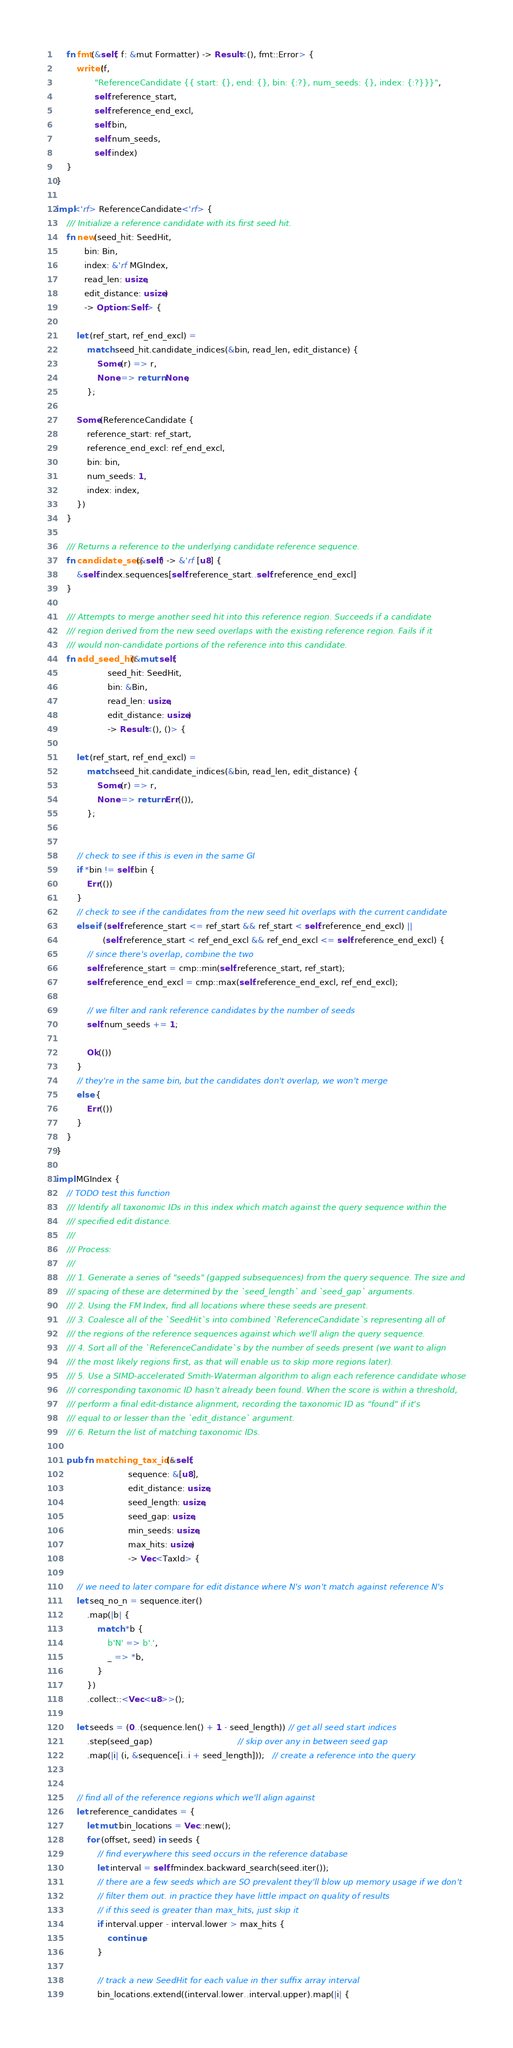<code> <loc_0><loc_0><loc_500><loc_500><_Rust_>    fn fmt(&self, f: &mut Formatter) -> Result<(), fmt::Error> {
        write!(f,
               "ReferenceCandidate {{ start: {}, end: {}, bin: {:?}, num_seeds: {}, index: {:?}}}",
               self.reference_start,
               self.reference_end_excl,
               self.bin,
               self.num_seeds,
               self.index)
    }
}

impl<'rf> ReferenceCandidate<'rf> {
    /// Initialize a reference candidate with its first seed hit.
    fn new(seed_hit: SeedHit,
           bin: Bin,
           index: &'rf MGIndex,
           read_len: usize,
           edit_distance: usize)
           -> Option<Self> {

        let (ref_start, ref_end_excl) =
            match seed_hit.candidate_indices(&bin, read_len, edit_distance) {
                Some(r) => r,
                None => return None,
            };

        Some(ReferenceCandidate {
            reference_start: ref_start,
            reference_end_excl: ref_end_excl,
            bin: bin,
            num_seeds: 1,
            index: index,
        })
    }

    /// Returns a reference to the underlying candidate reference sequence.
    fn candidate_seq(&self) -> &'rf [u8] {
        &self.index.sequences[self.reference_start..self.reference_end_excl]
    }

    /// Attempts to merge another seed hit into this reference region. Succeeds if a candidate
    /// region derived from the new seed overlaps with the existing reference region. Fails if it
    /// would non-candidate portions of the reference into this candidate.
    fn add_seed_hit(&mut self,
                    seed_hit: SeedHit,
                    bin: &Bin,
                    read_len: usize,
                    edit_distance: usize)
                    -> Result<(), ()> {

        let (ref_start, ref_end_excl) =
            match seed_hit.candidate_indices(&bin, read_len, edit_distance) {
                Some(r) => r,
                None => return Err(()),
            };


        // check to see if this is even in the same GI
        if *bin != self.bin {
            Err(())
        }
        // check to see if the candidates from the new seed hit overlaps with the current candidate
        else if (self.reference_start <= ref_start && ref_start < self.reference_end_excl) ||
                  (self.reference_start < ref_end_excl && ref_end_excl <= self.reference_end_excl) {
            // since there's overlap, combine the two
            self.reference_start = cmp::min(self.reference_start, ref_start);
            self.reference_end_excl = cmp::max(self.reference_end_excl, ref_end_excl);

            // we filter and rank reference candidates by the number of seeds
            self.num_seeds += 1;

            Ok(())
        }
        // they're in the same bin, but the candidates don't overlap, we won't merge
        else {
            Err(())
        }
    }
}

impl MGIndex {
    // TODO test this function
    /// Identify all taxonomic IDs in this index which match against the query sequence within the
    /// specified edit distance.
    ///
    /// Process:
    ///
    /// 1. Generate a series of "seeds" (gapped subsequences) from the query sequence. The size and
    /// spacing of these are determined by the `seed_length` and `seed_gap` arguments.
    /// 2. Using the FM Index, find all locations where these seeds are present.
    /// 3. Coalesce all of the `SeedHit`s into combined `ReferenceCandidate`s representing all of
    /// the regions of the reference sequences against which we'll align the query sequence.
    /// 4. Sort all of the `ReferenceCandidate`s by the number of seeds present (we want to align
    /// the most likely regions first, as that will enable us to skip more regions later).
    /// 5. Use a SIMD-accelerated Smith-Waterman algorithm to align each reference candidate whose
    /// corresponding taxonomic ID hasn't already been found. When the score is within a threshold,
    /// perform a final edit-distance alignment, recording the taxonomic ID as "found" if it's
    /// equal to or lesser than the `edit_distance` argument.
    /// 6. Return the list of matching taxonomic IDs.

    pub fn matching_tax_ids(&self,
                            sequence: &[u8],
                            edit_distance: usize,
                            seed_length: usize,
                            seed_gap: usize,
                            min_seeds: usize,
                            max_hits: usize)
                            -> Vec<TaxId> {

        // we need to later compare for edit distance where N's won't match against reference N's
        let seq_no_n = sequence.iter()
            .map(|b| {
                match *b {
                    b'N' => b'.',
                    _ => *b,
                }
            })
            .collect::<Vec<u8>>();

        let seeds = (0..(sequence.len() + 1 - seed_length)) // get all seed start indices
            .step(seed_gap)                                 // skip over any in between seed gap
            .map(|i| (i, &sequence[i..i + seed_length]));   // create a reference into the query


        // find all of the reference regions which we'll align against
        let reference_candidates = {
            let mut bin_locations = Vec::new();
            for (offset, seed) in seeds {
                // find everywhere this seed occurs in the reference database
                let interval = self.fmindex.backward_search(seed.iter());
                // there are a few seeds which are SO prevalent they'll blow up memory usage if we don't
                // filter them out. in practice they have little impact on quality of results
                // if this seed is greater than max_hits, just skip it
                if interval.upper - interval.lower > max_hits {
                    continue;
                }

                // track a new SeedHit for each value in ther suffix array interval
                bin_locations.extend((interval.lower..interval.upper).map(|i| {</code> 